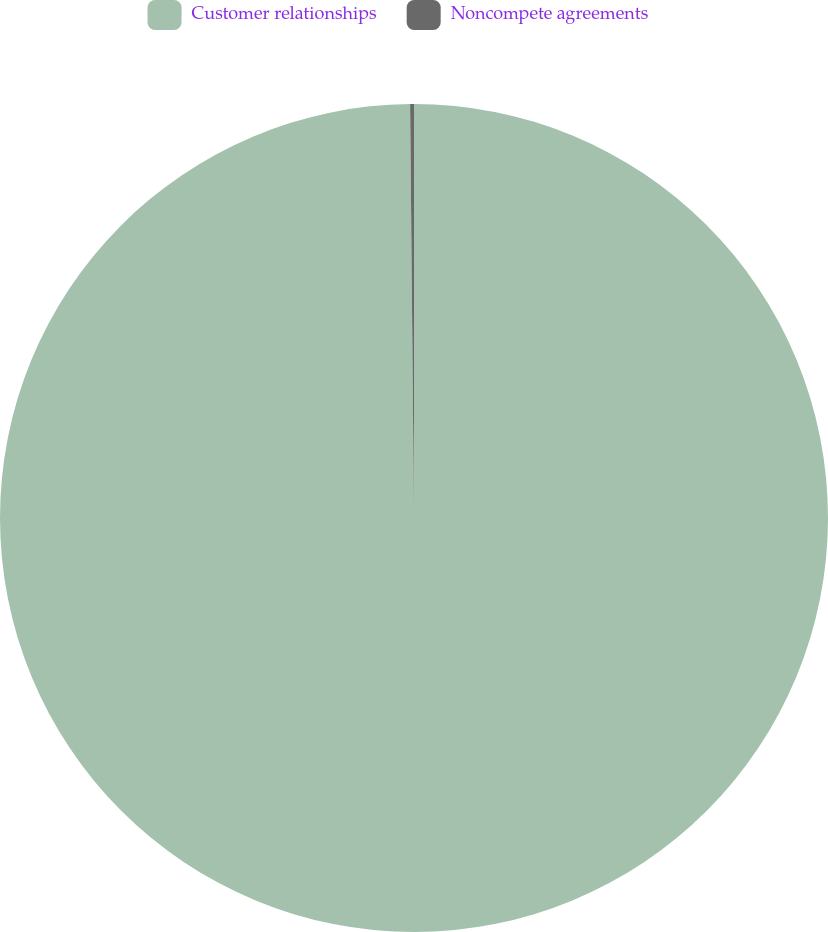Convert chart. <chart><loc_0><loc_0><loc_500><loc_500><pie_chart><fcel>Customer relationships<fcel>Noncompete agreements<nl><fcel>99.85%<fcel>0.15%<nl></chart> 